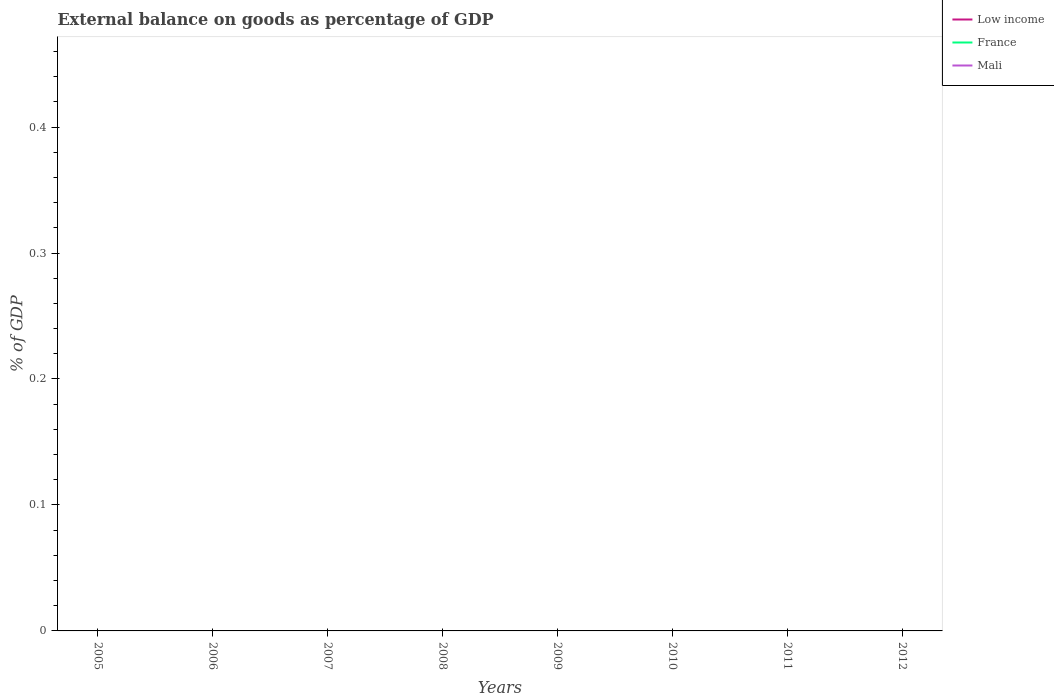Is the number of lines equal to the number of legend labels?
Provide a succinct answer. No. Across all years, what is the maximum external balance on goods as percentage of GDP in France?
Offer a terse response. 0. What is the difference between the highest and the lowest external balance on goods as percentage of GDP in Mali?
Provide a succinct answer. 0. How many lines are there?
Your response must be concise. 0. How many years are there in the graph?
Give a very brief answer. 8. What is the difference between two consecutive major ticks on the Y-axis?
Provide a short and direct response. 0.1. Does the graph contain any zero values?
Provide a succinct answer. Yes. How many legend labels are there?
Ensure brevity in your answer.  3. What is the title of the graph?
Offer a very short reply. External balance on goods as percentage of GDP. What is the label or title of the Y-axis?
Provide a succinct answer. % of GDP. What is the % of GDP of Low income in 2005?
Your answer should be very brief. 0. What is the % of GDP in Mali in 2005?
Provide a succinct answer. 0. What is the % of GDP in France in 2006?
Offer a terse response. 0. What is the % of GDP of Low income in 2008?
Your answer should be compact. 0. What is the % of GDP in Low income in 2009?
Ensure brevity in your answer.  0. What is the % of GDP in France in 2009?
Your response must be concise. 0. What is the % of GDP of Mali in 2009?
Your answer should be very brief. 0. What is the % of GDP of Low income in 2010?
Make the answer very short. 0. What is the % of GDP in France in 2010?
Your response must be concise. 0. What is the % of GDP in Low income in 2012?
Your answer should be compact. 0. What is the total % of GDP of Low income in the graph?
Ensure brevity in your answer.  0. What is the total % of GDP of Mali in the graph?
Give a very brief answer. 0. What is the average % of GDP in Low income per year?
Keep it short and to the point. 0. What is the average % of GDP of Mali per year?
Give a very brief answer. 0. 